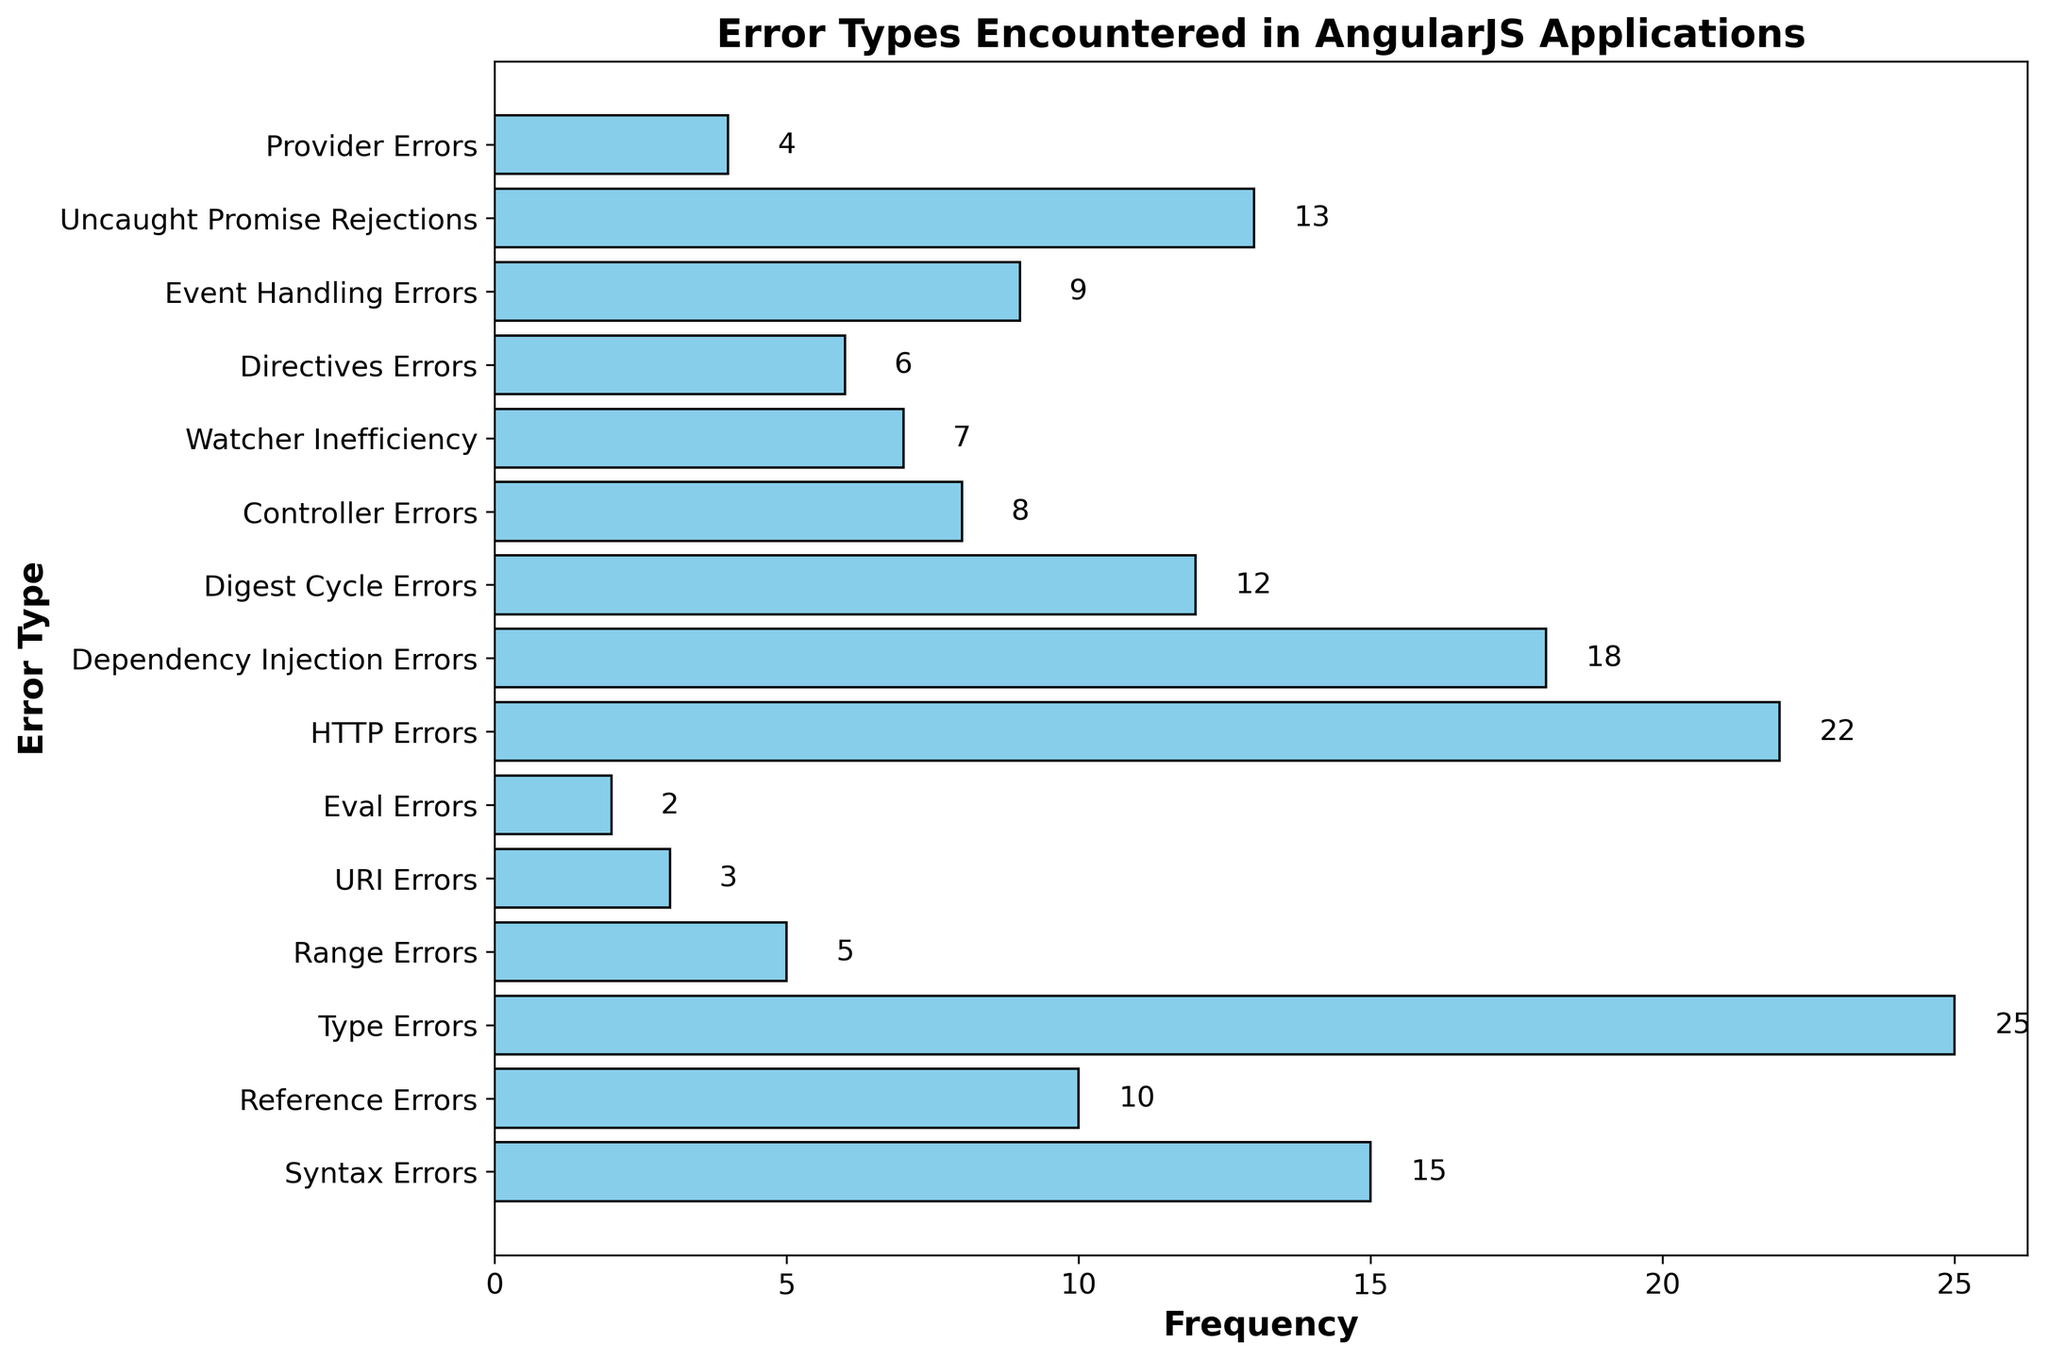Which error type has the highest frequency? Look for the bar with the greatest length. The longest bar corresponds to "Type Errors" with a frequency of 25.
Answer: Type Errors Which has more occurrences, HTTP Errors or Dependency Injection Errors? Compare the lengths of the bars for "HTTP Errors" and "Dependency Injection Errors." "HTTP Errors" has a frequency of 22, while "Dependency Injection Errors" has a frequency of 18.
Answer: HTTP Errors Which error type has the least frequency? Find the bar with the shortest length. The shortest bar corresponds to "Eval Errors" with a frequency of 2.
Answer: Eval Errors What is the total frequency of Watcher Inefficiency and Event Handling Errors? Sum the frequencies of "Watcher Inefficiency" (7) and "Event Handling Errors" (9). 7 + 9 = 16.
Answer: 16 How much more frequent are Type Errors than Digest Cycle Errors? Subtract the frequency of "Digest Cycle Errors" (12) from "Type Errors" (25). 25 - 12 = 13.
Answer: 13 Do Syntax Errors occur more often than Controller Errors? Compare the bars for "Syntax Errors" and "Controller Errors." "Syntax Errors" has a frequency of 15, while "Controller Errors" has a frequency of 8.
Answer: Yes What is the combined frequency of the three least frequent error types? The three least frequent error types are Eval Errors (2), URI Errors (3), and Range Errors (5). Sum their frequencies: 2 + 3 + 5 = 10.
Answer: 10 Which errors happen less frequently than Uncaught Promise Rejections? Find all error types with a lower frequency than "Uncaught Promise Rejections" which has a frequency of 13. These are Eval Errors (2), URI Errors (3), Range Errors (5), Provider Errors (4), Watcher Inefficiency (7), and Directives Errors (6).
Answer: Eval Errors, URI Errors, Range Errors, Provider Errors, Watcher Inefficiency, Directives Errors Are there more occurrences of HTTP Errors than the sum of URI Errors and Range Errors? Check if the frequency of "HTTP Errors" (22) is greater than the sum of "URI Errors" (3) and "Range Errors" (5). 3 + 5 = 8, and 22 > 8.
Answer: Yes Which error type is more frequent, Dependency Injection Errors or Digest Cycle Errors? Compare the bars for "Dependency Injection Errors" and "Digest Cycle Errors." "Dependency Injection Errors" has a frequency of 18, while "Digest Cycle Errors" has a frequency of 12.
Answer: Dependency Injection Errors 